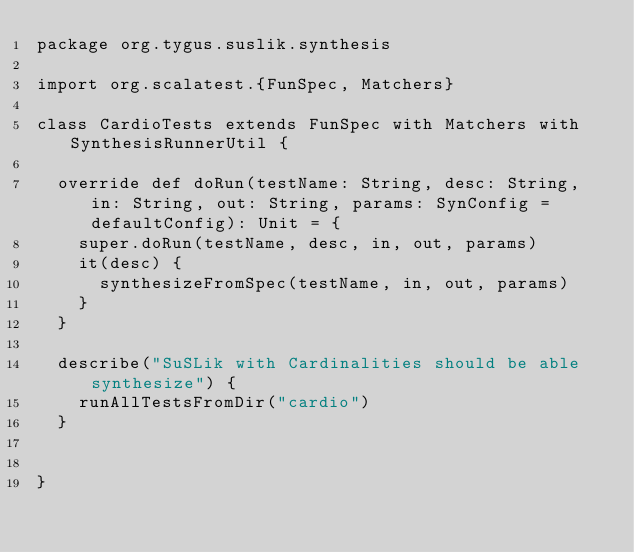Convert code to text. <code><loc_0><loc_0><loc_500><loc_500><_Scala_>package org.tygus.suslik.synthesis

import org.scalatest.{FunSpec, Matchers}

class CardioTests extends FunSpec with Matchers with SynthesisRunnerUtil {

  override def doRun(testName: String, desc: String, in: String, out: String, params: SynConfig = defaultConfig): Unit = {
    super.doRun(testName, desc, in, out, params)
    it(desc) {
      synthesizeFromSpec(testName, in, out, params)
    }
  }

  describe("SuSLik with Cardinalities should be able synthesize") {
    runAllTestsFromDir("cardio")
  }


}
</code> 